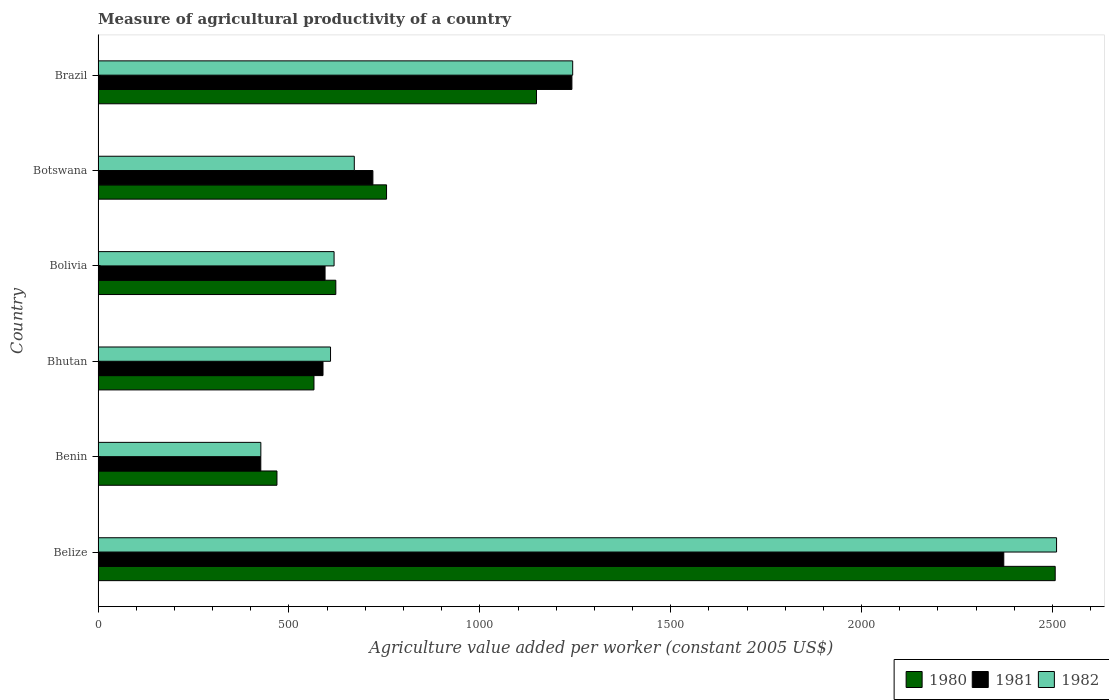What is the label of the 4th group of bars from the top?
Provide a succinct answer. Bhutan. In how many cases, is the number of bars for a given country not equal to the number of legend labels?
Offer a very short reply. 0. What is the measure of agricultural productivity in 1982 in Brazil?
Provide a short and direct response. 1243.26. Across all countries, what is the maximum measure of agricultural productivity in 1981?
Keep it short and to the point. 2372.54. Across all countries, what is the minimum measure of agricultural productivity in 1980?
Ensure brevity in your answer.  468.55. In which country was the measure of agricultural productivity in 1980 maximum?
Ensure brevity in your answer.  Belize. In which country was the measure of agricultural productivity in 1980 minimum?
Your answer should be very brief. Benin. What is the total measure of agricultural productivity in 1980 in the graph?
Offer a very short reply. 6068.2. What is the difference between the measure of agricultural productivity in 1980 in Belize and that in Bolivia?
Ensure brevity in your answer.  1884.5. What is the difference between the measure of agricultural productivity in 1981 in Bolivia and the measure of agricultural productivity in 1980 in Brazil?
Provide a short and direct response. -553.87. What is the average measure of agricultural productivity in 1981 per country?
Offer a terse response. 990.61. What is the difference between the measure of agricultural productivity in 1980 and measure of agricultural productivity in 1981 in Bolivia?
Offer a very short reply. 28.17. In how many countries, is the measure of agricultural productivity in 1980 greater than 2200 US$?
Offer a terse response. 1. What is the ratio of the measure of agricultural productivity in 1982 in Bolivia to that in Botswana?
Give a very brief answer. 0.92. Is the difference between the measure of agricultural productivity in 1980 in Bolivia and Botswana greater than the difference between the measure of agricultural productivity in 1981 in Bolivia and Botswana?
Offer a terse response. No. What is the difference between the highest and the second highest measure of agricultural productivity in 1980?
Your response must be concise. 1358.8. What is the difference between the highest and the lowest measure of agricultural productivity in 1982?
Ensure brevity in your answer.  2084.47. Is the sum of the measure of agricultural productivity in 1982 in Bolivia and Botswana greater than the maximum measure of agricultural productivity in 1980 across all countries?
Keep it short and to the point. No. What does the 2nd bar from the top in Brazil represents?
Your answer should be very brief. 1981. What does the 1st bar from the bottom in Belize represents?
Your answer should be very brief. 1980. Is it the case that in every country, the sum of the measure of agricultural productivity in 1981 and measure of agricultural productivity in 1982 is greater than the measure of agricultural productivity in 1980?
Give a very brief answer. Yes. Are all the bars in the graph horizontal?
Make the answer very short. Yes. Does the graph contain grids?
Offer a very short reply. No. Where does the legend appear in the graph?
Offer a terse response. Bottom right. How many legend labels are there?
Your response must be concise. 3. How are the legend labels stacked?
Ensure brevity in your answer.  Horizontal. What is the title of the graph?
Offer a very short reply. Measure of agricultural productivity of a country. Does "1990" appear as one of the legend labels in the graph?
Offer a very short reply. No. What is the label or title of the X-axis?
Make the answer very short. Agriculture value added per worker (constant 2005 US$). What is the label or title of the Y-axis?
Offer a terse response. Country. What is the Agriculture value added per worker (constant 2005 US$) of 1980 in Belize?
Ensure brevity in your answer.  2507.25. What is the Agriculture value added per worker (constant 2005 US$) of 1981 in Belize?
Offer a terse response. 2372.54. What is the Agriculture value added per worker (constant 2005 US$) of 1982 in Belize?
Your response must be concise. 2510.81. What is the Agriculture value added per worker (constant 2005 US$) of 1980 in Benin?
Your answer should be compact. 468.55. What is the Agriculture value added per worker (constant 2005 US$) of 1981 in Benin?
Ensure brevity in your answer.  426.23. What is the Agriculture value added per worker (constant 2005 US$) of 1982 in Benin?
Offer a very short reply. 426.34. What is the Agriculture value added per worker (constant 2005 US$) of 1980 in Bhutan?
Your answer should be compact. 565.54. What is the Agriculture value added per worker (constant 2005 US$) of 1981 in Bhutan?
Keep it short and to the point. 589.19. What is the Agriculture value added per worker (constant 2005 US$) of 1982 in Bhutan?
Your answer should be compact. 608.93. What is the Agriculture value added per worker (constant 2005 US$) of 1980 in Bolivia?
Provide a succinct answer. 622.75. What is the Agriculture value added per worker (constant 2005 US$) of 1981 in Bolivia?
Ensure brevity in your answer.  594.58. What is the Agriculture value added per worker (constant 2005 US$) in 1982 in Bolivia?
Your answer should be compact. 618.22. What is the Agriculture value added per worker (constant 2005 US$) in 1980 in Botswana?
Provide a succinct answer. 755.65. What is the Agriculture value added per worker (constant 2005 US$) of 1981 in Botswana?
Your answer should be very brief. 719.89. What is the Agriculture value added per worker (constant 2005 US$) in 1982 in Botswana?
Provide a succinct answer. 671.18. What is the Agriculture value added per worker (constant 2005 US$) of 1980 in Brazil?
Ensure brevity in your answer.  1148.46. What is the Agriculture value added per worker (constant 2005 US$) in 1981 in Brazil?
Give a very brief answer. 1241.2. What is the Agriculture value added per worker (constant 2005 US$) in 1982 in Brazil?
Offer a very short reply. 1243.26. Across all countries, what is the maximum Agriculture value added per worker (constant 2005 US$) of 1980?
Give a very brief answer. 2507.25. Across all countries, what is the maximum Agriculture value added per worker (constant 2005 US$) in 1981?
Your response must be concise. 2372.54. Across all countries, what is the maximum Agriculture value added per worker (constant 2005 US$) of 1982?
Provide a short and direct response. 2510.81. Across all countries, what is the minimum Agriculture value added per worker (constant 2005 US$) in 1980?
Your answer should be very brief. 468.55. Across all countries, what is the minimum Agriculture value added per worker (constant 2005 US$) in 1981?
Provide a succinct answer. 426.23. Across all countries, what is the minimum Agriculture value added per worker (constant 2005 US$) in 1982?
Ensure brevity in your answer.  426.34. What is the total Agriculture value added per worker (constant 2005 US$) in 1980 in the graph?
Your answer should be very brief. 6068.2. What is the total Agriculture value added per worker (constant 2005 US$) in 1981 in the graph?
Ensure brevity in your answer.  5943.63. What is the total Agriculture value added per worker (constant 2005 US$) of 1982 in the graph?
Give a very brief answer. 6078.74. What is the difference between the Agriculture value added per worker (constant 2005 US$) of 1980 in Belize and that in Benin?
Provide a succinct answer. 2038.7. What is the difference between the Agriculture value added per worker (constant 2005 US$) of 1981 in Belize and that in Benin?
Your response must be concise. 1946.32. What is the difference between the Agriculture value added per worker (constant 2005 US$) of 1982 in Belize and that in Benin?
Give a very brief answer. 2084.47. What is the difference between the Agriculture value added per worker (constant 2005 US$) of 1980 in Belize and that in Bhutan?
Your answer should be very brief. 1941.71. What is the difference between the Agriculture value added per worker (constant 2005 US$) in 1981 in Belize and that in Bhutan?
Provide a succinct answer. 1783.36. What is the difference between the Agriculture value added per worker (constant 2005 US$) of 1982 in Belize and that in Bhutan?
Provide a succinct answer. 1901.88. What is the difference between the Agriculture value added per worker (constant 2005 US$) of 1980 in Belize and that in Bolivia?
Ensure brevity in your answer.  1884.5. What is the difference between the Agriculture value added per worker (constant 2005 US$) of 1981 in Belize and that in Bolivia?
Offer a very short reply. 1777.96. What is the difference between the Agriculture value added per worker (constant 2005 US$) of 1982 in Belize and that in Bolivia?
Make the answer very short. 1892.59. What is the difference between the Agriculture value added per worker (constant 2005 US$) of 1980 in Belize and that in Botswana?
Ensure brevity in your answer.  1751.6. What is the difference between the Agriculture value added per worker (constant 2005 US$) in 1981 in Belize and that in Botswana?
Ensure brevity in your answer.  1652.66. What is the difference between the Agriculture value added per worker (constant 2005 US$) in 1982 in Belize and that in Botswana?
Your response must be concise. 1839.63. What is the difference between the Agriculture value added per worker (constant 2005 US$) of 1980 in Belize and that in Brazil?
Make the answer very short. 1358.8. What is the difference between the Agriculture value added per worker (constant 2005 US$) in 1981 in Belize and that in Brazil?
Ensure brevity in your answer.  1131.34. What is the difference between the Agriculture value added per worker (constant 2005 US$) in 1982 in Belize and that in Brazil?
Keep it short and to the point. 1267.55. What is the difference between the Agriculture value added per worker (constant 2005 US$) in 1980 in Benin and that in Bhutan?
Give a very brief answer. -96.98. What is the difference between the Agriculture value added per worker (constant 2005 US$) of 1981 in Benin and that in Bhutan?
Ensure brevity in your answer.  -162.96. What is the difference between the Agriculture value added per worker (constant 2005 US$) in 1982 in Benin and that in Bhutan?
Your answer should be very brief. -182.59. What is the difference between the Agriculture value added per worker (constant 2005 US$) in 1980 in Benin and that in Bolivia?
Provide a succinct answer. -154.2. What is the difference between the Agriculture value added per worker (constant 2005 US$) of 1981 in Benin and that in Bolivia?
Provide a short and direct response. -168.36. What is the difference between the Agriculture value added per worker (constant 2005 US$) in 1982 in Benin and that in Bolivia?
Offer a terse response. -191.88. What is the difference between the Agriculture value added per worker (constant 2005 US$) in 1980 in Benin and that in Botswana?
Offer a terse response. -287.1. What is the difference between the Agriculture value added per worker (constant 2005 US$) in 1981 in Benin and that in Botswana?
Provide a short and direct response. -293.66. What is the difference between the Agriculture value added per worker (constant 2005 US$) in 1982 in Benin and that in Botswana?
Offer a terse response. -244.84. What is the difference between the Agriculture value added per worker (constant 2005 US$) in 1980 in Benin and that in Brazil?
Ensure brevity in your answer.  -679.9. What is the difference between the Agriculture value added per worker (constant 2005 US$) in 1981 in Benin and that in Brazil?
Your response must be concise. -814.98. What is the difference between the Agriculture value added per worker (constant 2005 US$) in 1982 in Benin and that in Brazil?
Your answer should be very brief. -816.92. What is the difference between the Agriculture value added per worker (constant 2005 US$) in 1980 in Bhutan and that in Bolivia?
Ensure brevity in your answer.  -57.21. What is the difference between the Agriculture value added per worker (constant 2005 US$) of 1981 in Bhutan and that in Bolivia?
Provide a short and direct response. -5.39. What is the difference between the Agriculture value added per worker (constant 2005 US$) of 1982 in Bhutan and that in Bolivia?
Provide a short and direct response. -9.29. What is the difference between the Agriculture value added per worker (constant 2005 US$) in 1980 in Bhutan and that in Botswana?
Keep it short and to the point. -190.12. What is the difference between the Agriculture value added per worker (constant 2005 US$) of 1981 in Bhutan and that in Botswana?
Provide a short and direct response. -130.7. What is the difference between the Agriculture value added per worker (constant 2005 US$) of 1982 in Bhutan and that in Botswana?
Provide a short and direct response. -62.25. What is the difference between the Agriculture value added per worker (constant 2005 US$) of 1980 in Bhutan and that in Brazil?
Keep it short and to the point. -582.92. What is the difference between the Agriculture value added per worker (constant 2005 US$) of 1981 in Bhutan and that in Brazil?
Your response must be concise. -652.02. What is the difference between the Agriculture value added per worker (constant 2005 US$) of 1982 in Bhutan and that in Brazil?
Offer a very short reply. -634.33. What is the difference between the Agriculture value added per worker (constant 2005 US$) of 1980 in Bolivia and that in Botswana?
Keep it short and to the point. -132.9. What is the difference between the Agriculture value added per worker (constant 2005 US$) in 1981 in Bolivia and that in Botswana?
Offer a very short reply. -125.3. What is the difference between the Agriculture value added per worker (constant 2005 US$) of 1982 in Bolivia and that in Botswana?
Your response must be concise. -52.96. What is the difference between the Agriculture value added per worker (constant 2005 US$) in 1980 in Bolivia and that in Brazil?
Your answer should be compact. -525.7. What is the difference between the Agriculture value added per worker (constant 2005 US$) in 1981 in Bolivia and that in Brazil?
Keep it short and to the point. -646.62. What is the difference between the Agriculture value added per worker (constant 2005 US$) in 1982 in Bolivia and that in Brazil?
Offer a very short reply. -625.04. What is the difference between the Agriculture value added per worker (constant 2005 US$) of 1980 in Botswana and that in Brazil?
Your answer should be very brief. -392.8. What is the difference between the Agriculture value added per worker (constant 2005 US$) in 1981 in Botswana and that in Brazil?
Give a very brief answer. -521.32. What is the difference between the Agriculture value added per worker (constant 2005 US$) of 1982 in Botswana and that in Brazil?
Make the answer very short. -572.08. What is the difference between the Agriculture value added per worker (constant 2005 US$) of 1980 in Belize and the Agriculture value added per worker (constant 2005 US$) of 1981 in Benin?
Your response must be concise. 2081.03. What is the difference between the Agriculture value added per worker (constant 2005 US$) of 1980 in Belize and the Agriculture value added per worker (constant 2005 US$) of 1982 in Benin?
Your answer should be compact. 2080.91. What is the difference between the Agriculture value added per worker (constant 2005 US$) in 1981 in Belize and the Agriculture value added per worker (constant 2005 US$) in 1982 in Benin?
Keep it short and to the point. 1946.2. What is the difference between the Agriculture value added per worker (constant 2005 US$) in 1980 in Belize and the Agriculture value added per worker (constant 2005 US$) in 1981 in Bhutan?
Provide a short and direct response. 1918.06. What is the difference between the Agriculture value added per worker (constant 2005 US$) of 1980 in Belize and the Agriculture value added per worker (constant 2005 US$) of 1982 in Bhutan?
Provide a short and direct response. 1898.32. What is the difference between the Agriculture value added per worker (constant 2005 US$) in 1981 in Belize and the Agriculture value added per worker (constant 2005 US$) in 1982 in Bhutan?
Make the answer very short. 1763.62. What is the difference between the Agriculture value added per worker (constant 2005 US$) of 1980 in Belize and the Agriculture value added per worker (constant 2005 US$) of 1981 in Bolivia?
Give a very brief answer. 1912.67. What is the difference between the Agriculture value added per worker (constant 2005 US$) of 1980 in Belize and the Agriculture value added per worker (constant 2005 US$) of 1982 in Bolivia?
Your answer should be compact. 1889.03. What is the difference between the Agriculture value added per worker (constant 2005 US$) of 1981 in Belize and the Agriculture value added per worker (constant 2005 US$) of 1982 in Bolivia?
Give a very brief answer. 1754.33. What is the difference between the Agriculture value added per worker (constant 2005 US$) in 1980 in Belize and the Agriculture value added per worker (constant 2005 US$) in 1981 in Botswana?
Your answer should be very brief. 1787.36. What is the difference between the Agriculture value added per worker (constant 2005 US$) of 1980 in Belize and the Agriculture value added per worker (constant 2005 US$) of 1982 in Botswana?
Ensure brevity in your answer.  1836.07. What is the difference between the Agriculture value added per worker (constant 2005 US$) of 1981 in Belize and the Agriculture value added per worker (constant 2005 US$) of 1982 in Botswana?
Provide a short and direct response. 1701.36. What is the difference between the Agriculture value added per worker (constant 2005 US$) in 1980 in Belize and the Agriculture value added per worker (constant 2005 US$) in 1981 in Brazil?
Give a very brief answer. 1266.05. What is the difference between the Agriculture value added per worker (constant 2005 US$) of 1980 in Belize and the Agriculture value added per worker (constant 2005 US$) of 1982 in Brazil?
Ensure brevity in your answer.  1263.99. What is the difference between the Agriculture value added per worker (constant 2005 US$) of 1981 in Belize and the Agriculture value added per worker (constant 2005 US$) of 1982 in Brazil?
Provide a short and direct response. 1129.28. What is the difference between the Agriculture value added per worker (constant 2005 US$) in 1980 in Benin and the Agriculture value added per worker (constant 2005 US$) in 1981 in Bhutan?
Keep it short and to the point. -120.63. What is the difference between the Agriculture value added per worker (constant 2005 US$) of 1980 in Benin and the Agriculture value added per worker (constant 2005 US$) of 1982 in Bhutan?
Your answer should be very brief. -140.37. What is the difference between the Agriculture value added per worker (constant 2005 US$) in 1981 in Benin and the Agriculture value added per worker (constant 2005 US$) in 1982 in Bhutan?
Your response must be concise. -182.7. What is the difference between the Agriculture value added per worker (constant 2005 US$) of 1980 in Benin and the Agriculture value added per worker (constant 2005 US$) of 1981 in Bolivia?
Ensure brevity in your answer.  -126.03. What is the difference between the Agriculture value added per worker (constant 2005 US$) of 1980 in Benin and the Agriculture value added per worker (constant 2005 US$) of 1982 in Bolivia?
Your answer should be compact. -149.66. What is the difference between the Agriculture value added per worker (constant 2005 US$) in 1981 in Benin and the Agriculture value added per worker (constant 2005 US$) in 1982 in Bolivia?
Provide a short and direct response. -191.99. What is the difference between the Agriculture value added per worker (constant 2005 US$) of 1980 in Benin and the Agriculture value added per worker (constant 2005 US$) of 1981 in Botswana?
Keep it short and to the point. -251.33. What is the difference between the Agriculture value added per worker (constant 2005 US$) in 1980 in Benin and the Agriculture value added per worker (constant 2005 US$) in 1982 in Botswana?
Keep it short and to the point. -202.63. What is the difference between the Agriculture value added per worker (constant 2005 US$) in 1981 in Benin and the Agriculture value added per worker (constant 2005 US$) in 1982 in Botswana?
Your response must be concise. -244.96. What is the difference between the Agriculture value added per worker (constant 2005 US$) of 1980 in Benin and the Agriculture value added per worker (constant 2005 US$) of 1981 in Brazil?
Your response must be concise. -772.65. What is the difference between the Agriculture value added per worker (constant 2005 US$) in 1980 in Benin and the Agriculture value added per worker (constant 2005 US$) in 1982 in Brazil?
Keep it short and to the point. -774.71. What is the difference between the Agriculture value added per worker (constant 2005 US$) of 1981 in Benin and the Agriculture value added per worker (constant 2005 US$) of 1982 in Brazil?
Keep it short and to the point. -817.04. What is the difference between the Agriculture value added per worker (constant 2005 US$) in 1980 in Bhutan and the Agriculture value added per worker (constant 2005 US$) in 1981 in Bolivia?
Make the answer very short. -29.04. What is the difference between the Agriculture value added per worker (constant 2005 US$) in 1980 in Bhutan and the Agriculture value added per worker (constant 2005 US$) in 1982 in Bolivia?
Offer a very short reply. -52.68. What is the difference between the Agriculture value added per worker (constant 2005 US$) in 1981 in Bhutan and the Agriculture value added per worker (constant 2005 US$) in 1982 in Bolivia?
Keep it short and to the point. -29.03. What is the difference between the Agriculture value added per worker (constant 2005 US$) of 1980 in Bhutan and the Agriculture value added per worker (constant 2005 US$) of 1981 in Botswana?
Your answer should be compact. -154.35. What is the difference between the Agriculture value added per worker (constant 2005 US$) in 1980 in Bhutan and the Agriculture value added per worker (constant 2005 US$) in 1982 in Botswana?
Offer a terse response. -105.64. What is the difference between the Agriculture value added per worker (constant 2005 US$) in 1981 in Bhutan and the Agriculture value added per worker (constant 2005 US$) in 1982 in Botswana?
Provide a succinct answer. -81.99. What is the difference between the Agriculture value added per worker (constant 2005 US$) in 1980 in Bhutan and the Agriculture value added per worker (constant 2005 US$) in 1981 in Brazil?
Provide a short and direct response. -675.67. What is the difference between the Agriculture value added per worker (constant 2005 US$) in 1980 in Bhutan and the Agriculture value added per worker (constant 2005 US$) in 1982 in Brazil?
Keep it short and to the point. -677.72. What is the difference between the Agriculture value added per worker (constant 2005 US$) in 1981 in Bhutan and the Agriculture value added per worker (constant 2005 US$) in 1982 in Brazil?
Your answer should be very brief. -654.07. What is the difference between the Agriculture value added per worker (constant 2005 US$) of 1980 in Bolivia and the Agriculture value added per worker (constant 2005 US$) of 1981 in Botswana?
Keep it short and to the point. -97.14. What is the difference between the Agriculture value added per worker (constant 2005 US$) of 1980 in Bolivia and the Agriculture value added per worker (constant 2005 US$) of 1982 in Botswana?
Your answer should be compact. -48.43. What is the difference between the Agriculture value added per worker (constant 2005 US$) of 1981 in Bolivia and the Agriculture value added per worker (constant 2005 US$) of 1982 in Botswana?
Ensure brevity in your answer.  -76.6. What is the difference between the Agriculture value added per worker (constant 2005 US$) in 1980 in Bolivia and the Agriculture value added per worker (constant 2005 US$) in 1981 in Brazil?
Make the answer very short. -618.45. What is the difference between the Agriculture value added per worker (constant 2005 US$) in 1980 in Bolivia and the Agriculture value added per worker (constant 2005 US$) in 1982 in Brazil?
Ensure brevity in your answer.  -620.51. What is the difference between the Agriculture value added per worker (constant 2005 US$) in 1981 in Bolivia and the Agriculture value added per worker (constant 2005 US$) in 1982 in Brazil?
Your answer should be compact. -648.68. What is the difference between the Agriculture value added per worker (constant 2005 US$) in 1980 in Botswana and the Agriculture value added per worker (constant 2005 US$) in 1981 in Brazil?
Your response must be concise. -485.55. What is the difference between the Agriculture value added per worker (constant 2005 US$) of 1980 in Botswana and the Agriculture value added per worker (constant 2005 US$) of 1982 in Brazil?
Give a very brief answer. -487.61. What is the difference between the Agriculture value added per worker (constant 2005 US$) in 1981 in Botswana and the Agriculture value added per worker (constant 2005 US$) in 1982 in Brazil?
Make the answer very short. -523.37. What is the average Agriculture value added per worker (constant 2005 US$) of 1980 per country?
Your answer should be very brief. 1011.37. What is the average Agriculture value added per worker (constant 2005 US$) of 1981 per country?
Your answer should be very brief. 990.61. What is the average Agriculture value added per worker (constant 2005 US$) in 1982 per country?
Provide a short and direct response. 1013.12. What is the difference between the Agriculture value added per worker (constant 2005 US$) in 1980 and Agriculture value added per worker (constant 2005 US$) in 1981 in Belize?
Make the answer very short. 134.71. What is the difference between the Agriculture value added per worker (constant 2005 US$) of 1980 and Agriculture value added per worker (constant 2005 US$) of 1982 in Belize?
Provide a short and direct response. -3.56. What is the difference between the Agriculture value added per worker (constant 2005 US$) of 1981 and Agriculture value added per worker (constant 2005 US$) of 1982 in Belize?
Your response must be concise. -138.27. What is the difference between the Agriculture value added per worker (constant 2005 US$) of 1980 and Agriculture value added per worker (constant 2005 US$) of 1981 in Benin?
Your response must be concise. 42.33. What is the difference between the Agriculture value added per worker (constant 2005 US$) in 1980 and Agriculture value added per worker (constant 2005 US$) in 1982 in Benin?
Your answer should be compact. 42.21. What is the difference between the Agriculture value added per worker (constant 2005 US$) in 1981 and Agriculture value added per worker (constant 2005 US$) in 1982 in Benin?
Give a very brief answer. -0.12. What is the difference between the Agriculture value added per worker (constant 2005 US$) in 1980 and Agriculture value added per worker (constant 2005 US$) in 1981 in Bhutan?
Offer a very short reply. -23.65. What is the difference between the Agriculture value added per worker (constant 2005 US$) of 1980 and Agriculture value added per worker (constant 2005 US$) of 1982 in Bhutan?
Your answer should be very brief. -43.39. What is the difference between the Agriculture value added per worker (constant 2005 US$) in 1981 and Agriculture value added per worker (constant 2005 US$) in 1982 in Bhutan?
Offer a very short reply. -19.74. What is the difference between the Agriculture value added per worker (constant 2005 US$) of 1980 and Agriculture value added per worker (constant 2005 US$) of 1981 in Bolivia?
Your answer should be very brief. 28.17. What is the difference between the Agriculture value added per worker (constant 2005 US$) in 1980 and Agriculture value added per worker (constant 2005 US$) in 1982 in Bolivia?
Offer a very short reply. 4.53. What is the difference between the Agriculture value added per worker (constant 2005 US$) of 1981 and Agriculture value added per worker (constant 2005 US$) of 1982 in Bolivia?
Provide a succinct answer. -23.63. What is the difference between the Agriculture value added per worker (constant 2005 US$) in 1980 and Agriculture value added per worker (constant 2005 US$) in 1981 in Botswana?
Provide a succinct answer. 35.77. What is the difference between the Agriculture value added per worker (constant 2005 US$) in 1980 and Agriculture value added per worker (constant 2005 US$) in 1982 in Botswana?
Keep it short and to the point. 84.47. What is the difference between the Agriculture value added per worker (constant 2005 US$) of 1981 and Agriculture value added per worker (constant 2005 US$) of 1982 in Botswana?
Offer a terse response. 48.71. What is the difference between the Agriculture value added per worker (constant 2005 US$) of 1980 and Agriculture value added per worker (constant 2005 US$) of 1981 in Brazil?
Ensure brevity in your answer.  -92.75. What is the difference between the Agriculture value added per worker (constant 2005 US$) of 1980 and Agriculture value added per worker (constant 2005 US$) of 1982 in Brazil?
Offer a very short reply. -94.81. What is the difference between the Agriculture value added per worker (constant 2005 US$) in 1981 and Agriculture value added per worker (constant 2005 US$) in 1982 in Brazil?
Provide a succinct answer. -2.06. What is the ratio of the Agriculture value added per worker (constant 2005 US$) in 1980 in Belize to that in Benin?
Your answer should be compact. 5.35. What is the ratio of the Agriculture value added per worker (constant 2005 US$) of 1981 in Belize to that in Benin?
Keep it short and to the point. 5.57. What is the ratio of the Agriculture value added per worker (constant 2005 US$) in 1982 in Belize to that in Benin?
Offer a terse response. 5.89. What is the ratio of the Agriculture value added per worker (constant 2005 US$) in 1980 in Belize to that in Bhutan?
Your response must be concise. 4.43. What is the ratio of the Agriculture value added per worker (constant 2005 US$) in 1981 in Belize to that in Bhutan?
Keep it short and to the point. 4.03. What is the ratio of the Agriculture value added per worker (constant 2005 US$) of 1982 in Belize to that in Bhutan?
Provide a short and direct response. 4.12. What is the ratio of the Agriculture value added per worker (constant 2005 US$) in 1980 in Belize to that in Bolivia?
Give a very brief answer. 4.03. What is the ratio of the Agriculture value added per worker (constant 2005 US$) of 1981 in Belize to that in Bolivia?
Provide a succinct answer. 3.99. What is the ratio of the Agriculture value added per worker (constant 2005 US$) of 1982 in Belize to that in Bolivia?
Give a very brief answer. 4.06. What is the ratio of the Agriculture value added per worker (constant 2005 US$) in 1980 in Belize to that in Botswana?
Provide a short and direct response. 3.32. What is the ratio of the Agriculture value added per worker (constant 2005 US$) in 1981 in Belize to that in Botswana?
Give a very brief answer. 3.3. What is the ratio of the Agriculture value added per worker (constant 2005 US$) in 1982 in Belize to that in Botswana?
Provide a short and direct response. 3.74. What is the ratio of the Agriculture value added per worker (constant 2005 US$) in 1980 in Belize to that in Brazil?
Your answer should be compact. 2.18. What is the ratio of the Agriculture value added per worker (constant 2005 US$) in 1981 in Belize to that in Brazil?
Provide a short and direct response. 1.91. What is the ratio of the Agriculture value added per worker (constant 2005 US$) of 1982 in Belize to that in Brazil?
Provide a succinct answer. 2.02. What is the ratio of the Agriculture value added per worker (constant 2005 US$) in 1980 in Benin to that in Bhutan?
Your response must be concise. 0.83. What is the ratio of the Agriculture value added per worker (constant 2005 US$) of 1981 in Benin to that in Bhutan?
Ensure brevity in your answer.  0.72. What is the ratio of the Agriculture value added per worker (constant 2005 US$) in 1982 in Benin to that in Bhutan?
Your answer should be very brief. 0.7. What is the ratio of the Agriculture value added per worker (constant 2005 US$) in 1980 in Benin to that in Bolivia?
Make the answer very short. 0.75. What is the ratio of the Agriculture value added per worker (constant 2005 US$) in 1981 in Benin to that in Bolivia?
Provide a short and direct response. 0.72. What is the ratio of the Agriculture value added per worker (constant 2005 US$) of 1982 in Benin to that in Bolivia?
Ensure brevity in your answer.  0.69. What is the ratio of the Agriculture value added per worker (constant 2005 US$) in 1980 in Benin to that in Botswana?
Provide a short and direct response. 0.62. What is the ratio of the Agriculture value added per worker (constant 2005 US$) in 1981 in Benin to that in Botswana?
Your response must be concise. 0.59. What is the ratio of the Agriculture value added per worker (constant 2005 US$) of 1982 in Benin to that in Botswana?
Ensure brevity in your answer.  0.64. What is the ratio of the Agriculture value added per worker (constant 2005 US$) in 1980 in Benin to that in Brazil?
Your answer should be compact. 0.41. What is the ratio of the Agriculture value added per worker (constant 2005 US$) of 1981 in Benin to that in Brazil?
Keep it short and to the point. 0.34. What is the ratio of the Agriculture value added per worker (constant 2005 US$) in 1982 in Benin to that in Brazil?
Your answer should be compact. 0.34. What is the ratio of the Agriculture value added per worker (constant 2005 US$) in 1980 in Bhutan to that in Bolivia?
Keep it short and to the point. 0.91. What is the ratio of the Agriculture value added per worker (constant 2005 US$) in 1981 in Bhutan to that in Bolivia?
Your answer should be very brief. 0.99. What is the ratio of the Agriculture value added per worker (constant 2005 US$) of 1982 in Bhutan to that in Bolivia?
Your answer should be compact. 0.98. What is the ratio of the Agriculture value added per worker (constant 2005 US$) in 1980 in Bhutan to that in Botswana?
Provide a succinct answer. 0.75. What is the ratio of the Agriculture value added per worker (constant 2005 US$) in 1981 in Bhutan to that in Botswana?
Make the answer very short. 0.82. What is the ratio of the Agriculture value added per worker (constant 2005 US$) in 1982 in Bhutan to that in Botswana?
Provide a succinct answer. 0.91. What is the ratio of the Agriculture value added per worker (constant 2005 US$) in 1980 in Bhutan to that in Brazil?
Your response must be concise. 0.49. What is the ratio of the Agriculture value added per worker (constant 2005 US$) of 1981 in Bhutan to that in Brazil?
Keep it short and to the point. 0.47. What is the ratio of the Agriculture value added per worker (constant 2005 US$) in 1982 in Bhutan to that in Brazil?
Your answer should be very brief. 0.49. What is the ratio of the Agriculture value added per worker (constant 2005 US$) of 1980 in Bolivia to that in Botswana?
Your response must be concise. 0.82. What is the ratio of the Agriculture value added per worker (constant 2005 US$) in 1981 in Bolivia to that in Botswana?
Ensure brevity in your answer.  0.83. What is the ratio of the Agriculture value added per worker (constant 2005 US$) in 1982 in Bolivia to that in Botswana?
Your response must be concise. 0.92. What is the ratio of the Agriculture value added per worker (constant 2005 US$) in 1980 in Bolivia to that in Brazil?
Ensure brevity in your answer.  0.54. What is the ratio of the Agriculture value added per worker (constant 2005 US$) in 1981 in Bolivia to that in Brazil?
Give a very brief answer. 0.48. What is the ratio of the Agriculture value added per worker (constant 2005 US$) of 1982 in Bolivia to that in Brazil?
Your response must be concise. 0.5. What is the ratio of the Agriculture value added per worker (constant 2005 US$) of 1980 in Botswana to that in Brazil?
Offer a very short reply. 0.66. What is the ratio of the Agriculture value added per worker (constant 2005 US$) in 1981 in Botswana to that in Brazil?
Your response must be concise. 0.58. What is the ratio of the Agriculture value added per worker (constant 2005 US$) of 1982 in Botswana to that in Brazil?
Your answer should be very brief. 0.54. What is the difference between the highest and the second highest Agriculture value added per worker (constant 2005 US$) of 1980?
Keep it short and to the point. 1358.8. What is the difference between the highest and the second highest Agriculture value added per worker (constant 2005 US$) of 1981?
Your answer should be very brief. 1131.34. What is the difference between the highest and the second highest Agriculture value added per worker (constant 2005 US$) in 1982?
Keep it short and to the point. 1267.55. What is the difference between the highest and the lowest Agriculture value added per worker (constant 2005 US$) in 1980?
Your response must be concise. 2038.7. What is the difference between the highest and the lowest Agriculture value added per worker (constant 2005 US$) in 1981?
Ensure brevity in your answer.  1946.32. What is the difference between the highest and the lowest Agriculture value added per worker (constant 2005 US$) in 1982?
Keep it short and to the point. 2084.47. 